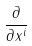<formula> <loc_0><loc_0><loc_500><loc_500>\frac { \partial } { \partial x ^ { i } }</formula> 